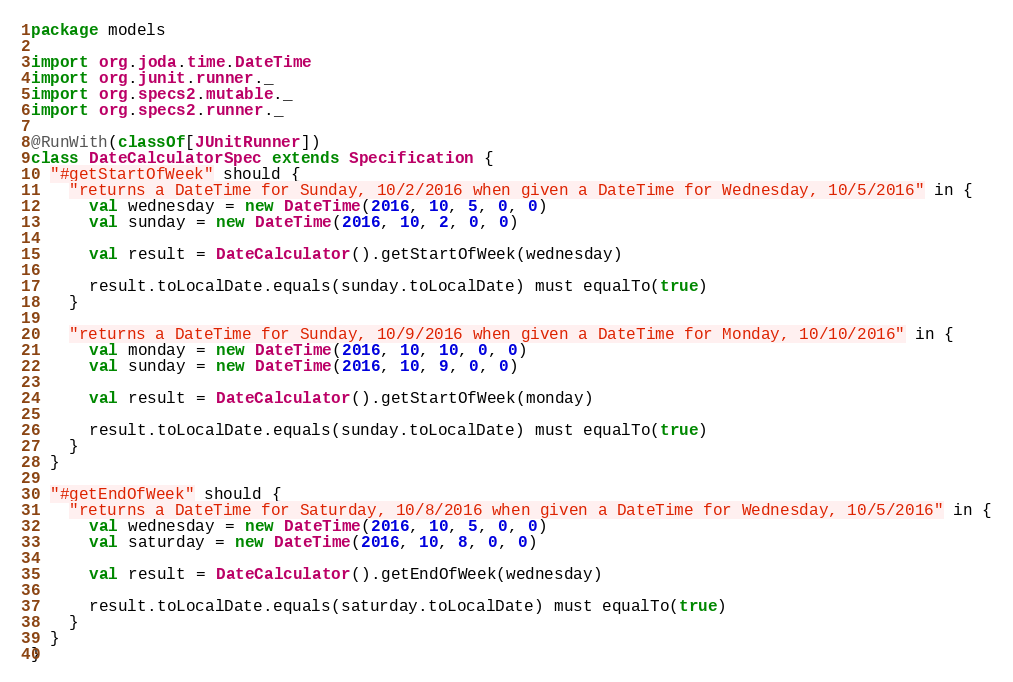<code> <loc_0><loc_0><loc_500><loc_500><_Scala_>package models

import org.joda.time.DateTime
import org.junit.runner._
import org.specs2.mutable._
import org.specs2.runner._

@RunWith(classOf[JUnitRunner])
class DateCalculatorSpec extends Specification {
  "#getStartOfWeek" should {
    "returns a DateTime for Sunday, 10/2/2016 when given a DateTime for Wednesday, 10/5/2016" in {
      val wednesday = new DateTime(2016, 10, 5, 0, 0)
      val sunday = new DateTime(2016, 10, 2, 0, 0)

      val result = DateCalculator().getStartOfWeek(wednesday)

      result.toLocalDate.equals(sunday.toLocalDate) must equalTo(true)
    }

    "returns a DateTime for Sunday, 10/9/2016 when given a DateTime for Monday, 10/10/2016" in {
      val monday = new DateTime(2016, 10, 10, 0, 0)
      val sunday = new DateTime(2016, 10, 9, 0, 0)

      val result = DateCalculator().getStartOfWeek(monday)

      result.toLocalDate.equals(sunday.toLocalDate) must equalTo(true)
    }
  }

  "#getEndOfWeek" should {
    "returns a DateTime for Saturday, 10/8/2016 when given a DateTime for Wednesday, 10/5/2016" in {
      val wednesday = new DateTime(2016, 10, 5, 0, 0)
      val saturday = new DateTime(2016, 10, 8, 0, 0)

      val result = DateCalculator().getEndOfWeek(wednesday)

      result.toLocalDate.equals(saturday.toLocalDate) must equalTo(true)
    }
  }
}
</code> 